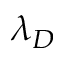Convert formula to latex. <formula><loc_0><loc_0><loc_500><loc_500>\lambda _ { D }</formula> 